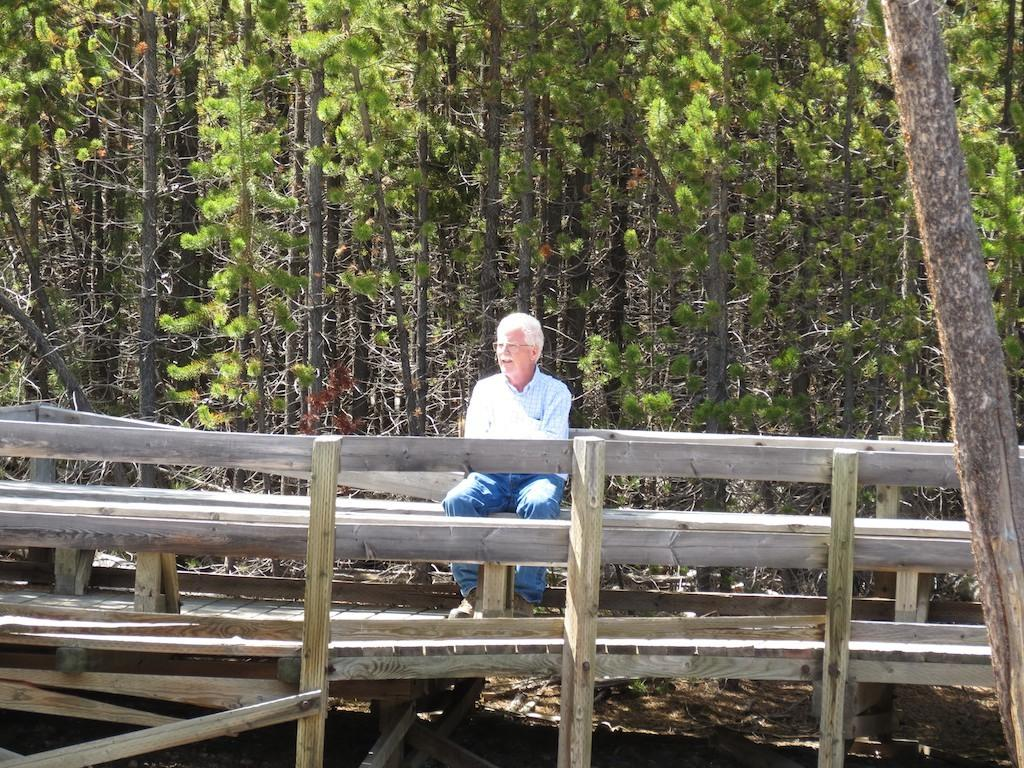What is the man in the image doing? The man is sitting in the image. What can be seen in the background of the image? There are trees and a wooden fence in the background of the image. Are there any other objects visible in the background? Yes, there are other objects visible in the background of the image. What type of faucet can be seen in the image? There is no faucet present in the image. How does the man say good-bye to someone in the image? The image does not show the man interacting with anyone, so it is not possible to determine how he might say good-bye. 